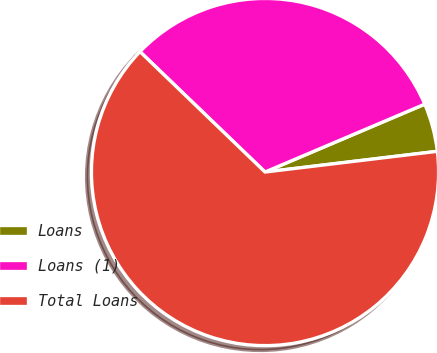<chart> <loc_0><loc_0><loc_500><loc_500><pie_chart><fcel>Loans<fcel>Loans (1)<fcel>Total Loans<nl><fcel>4.49%<fcel>31.41%<fcel>64.1%<nl></chart> 